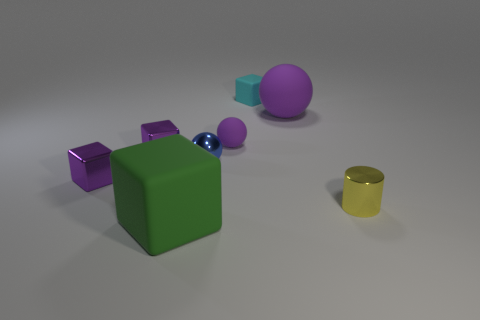Subtract all big blocks. How many blocks are left? 3 Add 1 large yellow spheres. How many objects exist? 9 Subtract all green blocks. How many blocks are left? 3 Subtract all balls. How many objects are left? 5 Subtract all brown spheres. How many purple blocks are left? 2 Add 5 large green cubes. How many large green cubes are left? 6 Add 1 gray balls. How many gray balls exist? 1 Subtract 1 cyan cubes. How many objects are left? 7 Subtract 2 cubes. How many cubes are left? 2 Subtract all blue balls. Subtract all yellow cylinders. How many balls are left? 2 